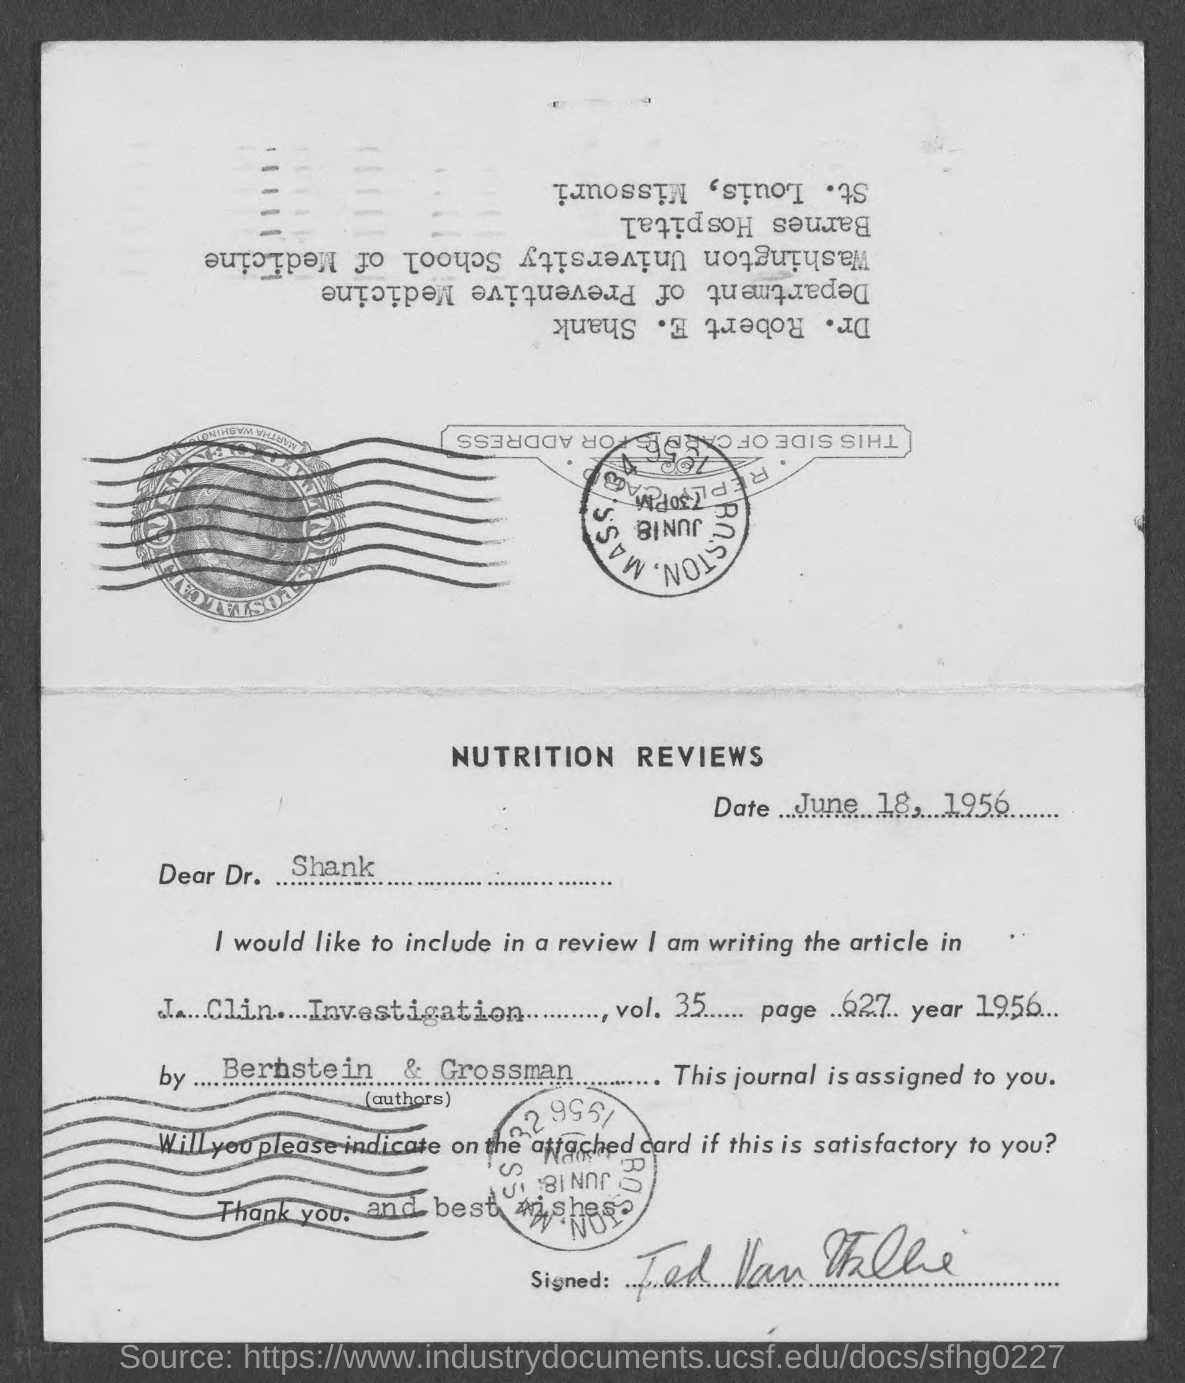Highlight a few significant elements in this photo. The date mentioned in the document is June 18, 1956. The mentioned article can be found on page 627 of the document. The document is addressed to Dr. Shank. 